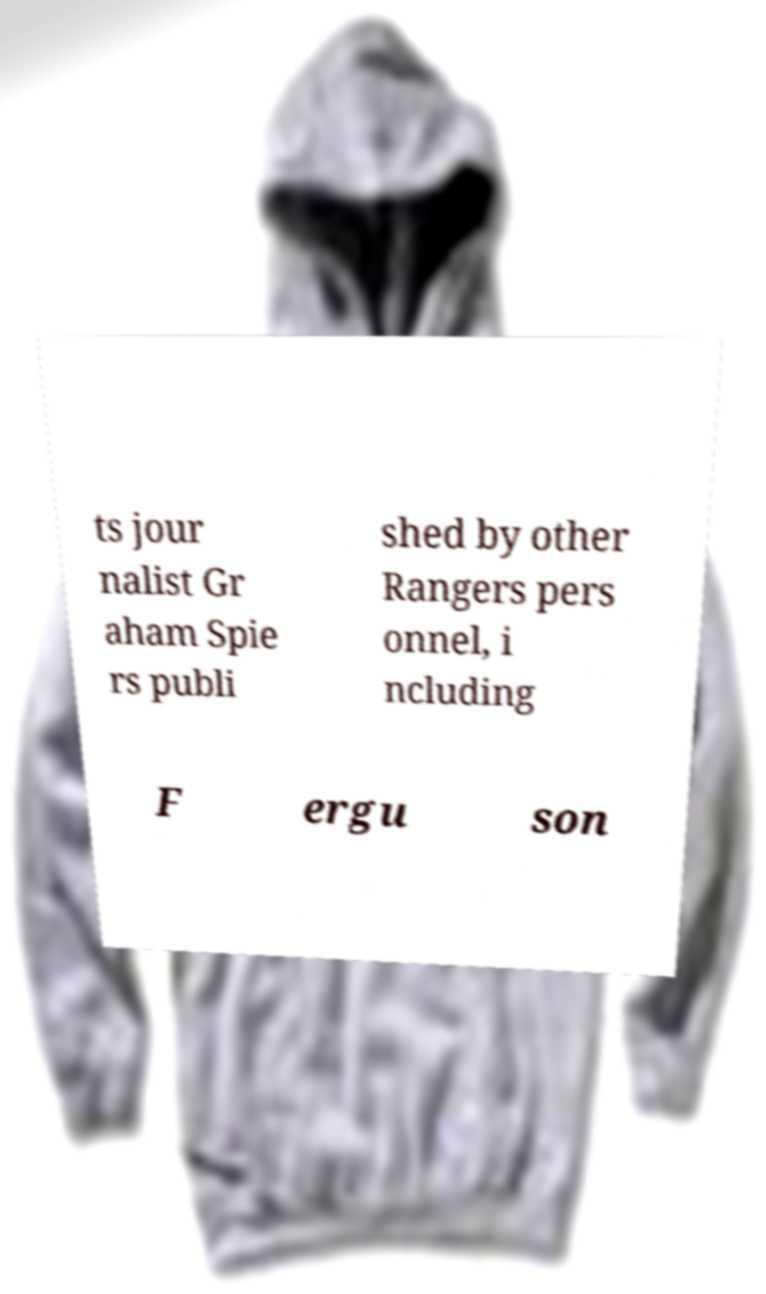Can you read and provide the text displayed in the image?This photo seems to have some interesting text. Can you extract and type it out for me? ts jour nalist Gr aham Spie rs publi shed by other Rangers pers onnel, i ncluding F ergu son 